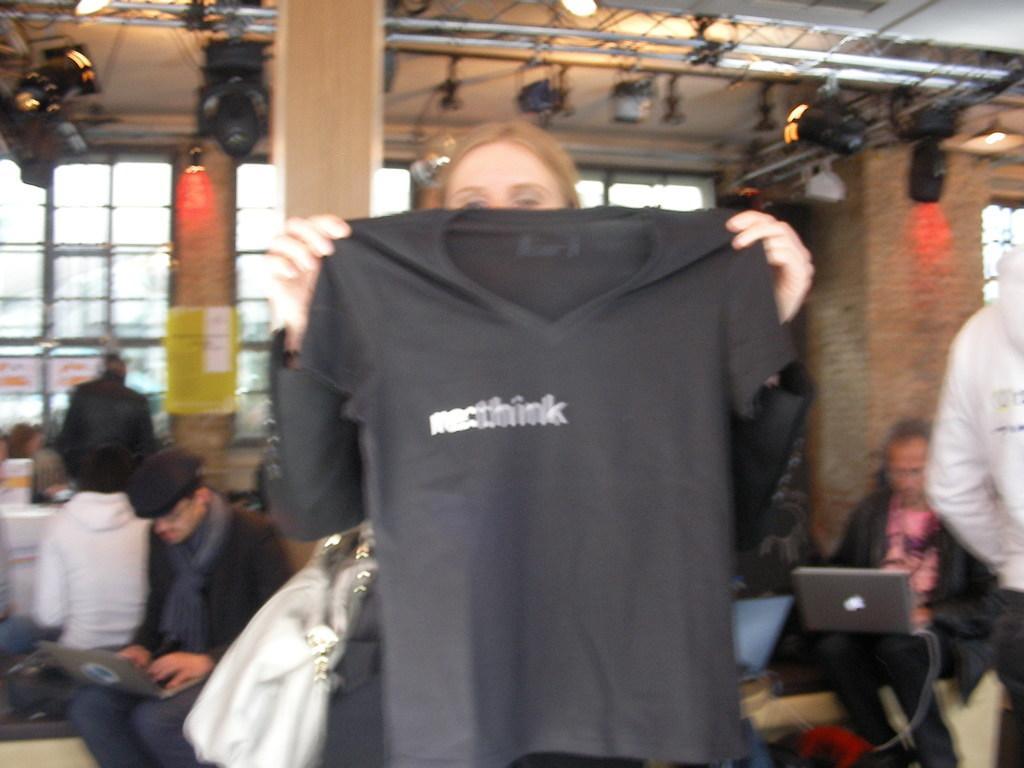Please provide a concise description of this image. In this picture we can see a person is holding a t shirt. Behind her there are two persons holding laptops. Behind the two persons there are people, pillars, glass windows. At the top of the picture there are lights and truss. 